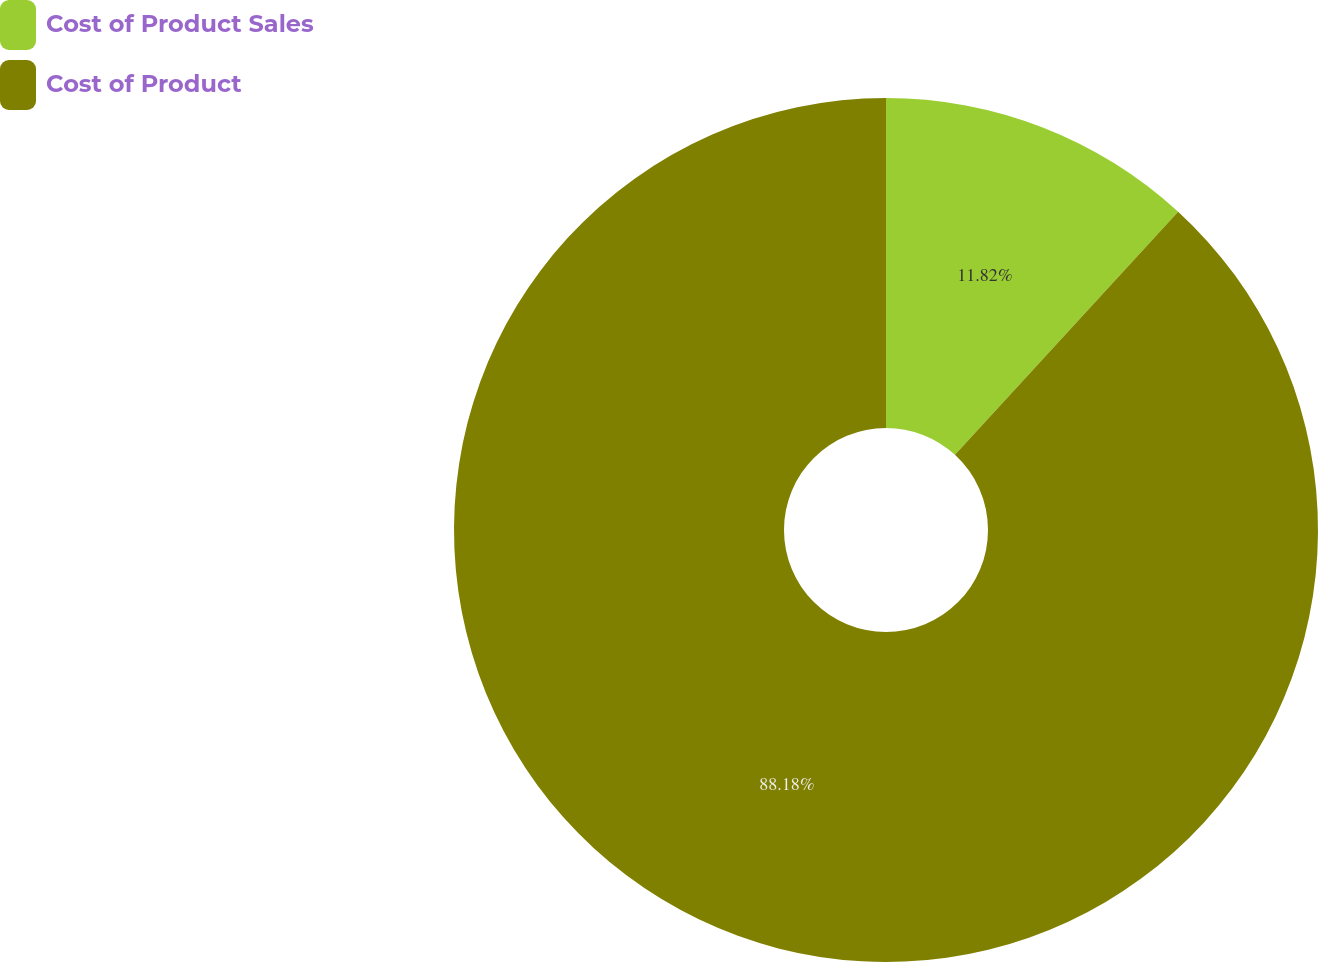Convert chart. <chart><loc_0><loc_0><loc_500><loc_500><pie_chart><fcel>Cost of Product Sales<fcel>Cost of Product<nl><fcel>11.82%<fcel>88.18%<nl></chart> 